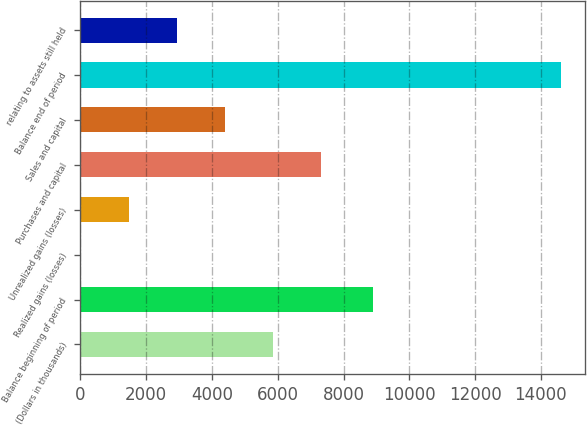Convert chart to OTSL. <chart><loc_0><loc_0><loc_500><loc_500><bar_chart><fcel>(Dollars in thousands)<fcel>Balance beginning of period<fcel>Realized gains (losses)<fcel>Unrealized gains (losses)<fcel>Purchases and capital<fcel>Sales and capital<fcel>Balance end of period<fcel>relating to assets still held<nl><fcel>5859.6<fcel>8882<fcel>22<fcel>1481.4<fcel>7319<fcel>4400.2<fcel>14616<fcel>2940.8<nl></chart> 